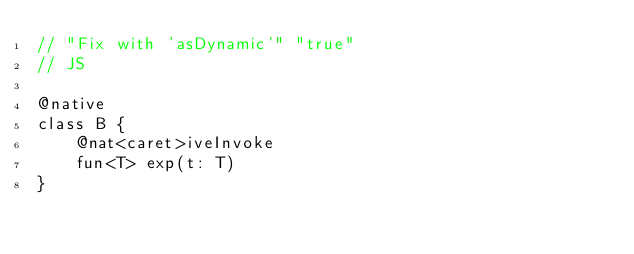Convert code to text. <code><loc_0><loc_0><loc_500><loc_500><_Kotlin_>// "Fix with 'asDynamic'" "true"
// JS

@native
class B {
    @nat<caret>iveInvoke
    fun<T> exp(t: T)
}
</code> 